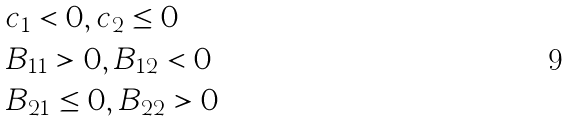Convert formula to latex. <formula><loc_0><loc_0><loc_500><loc_500>& c _ { 1 } < 0 , c _ { 2 } \leq 0 \\ & B _ { 1 1 } > 0 , B _ { 1 2 } < 0 \\ & B _ { 2 1 } \leq 0 , B _ { 2 2 } > 0</formula> 